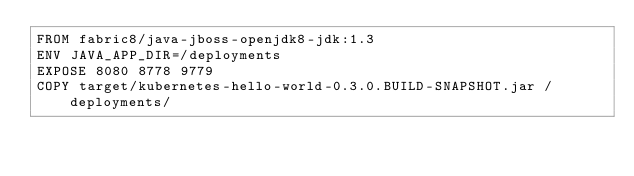Convert code to text. <code><loc_0><loc_0><loc_500><loc_500><_Dockerfile_>FROM fabric8/java-jboss-openjdk8-jdk:1.3
ENV JAVA_APP_DIR=/deployments
EXPOSE 8080 8778 9779
COPY target/kubernetes-hello-world-0.3.0.BUILD-SNAPSHOT.jar /deployments/
</code> 